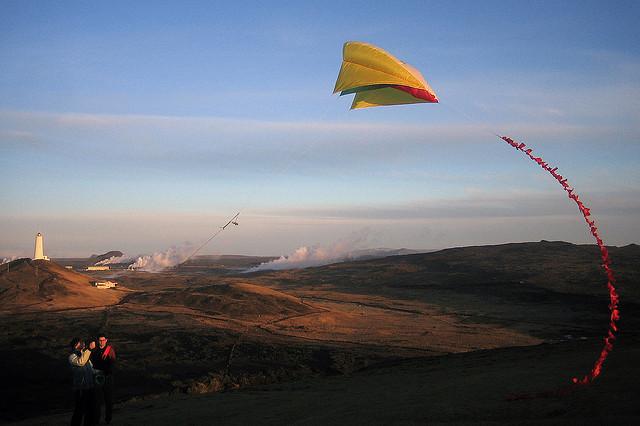What color is the tail of the kite?
Be succinct. Red. How many people are flying the kite?
Be succinct. 2. What is in the background of the photograph?
Write a very short answer. Lighthouse. 